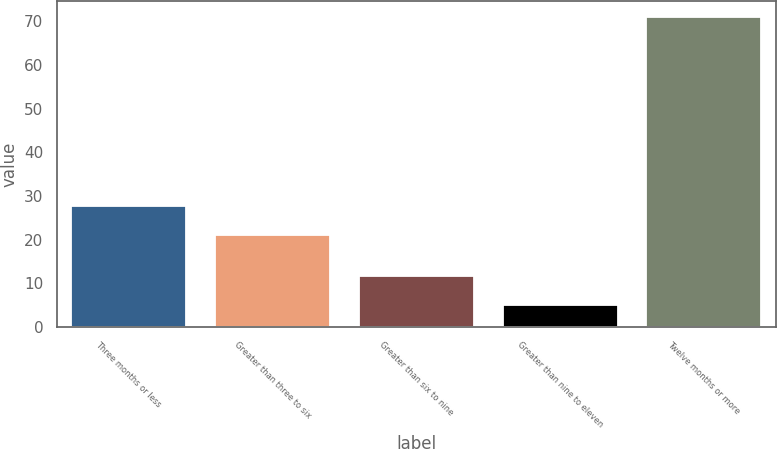<chart> <loc_0><loc_0><loc_500><loc_500><bar_chart><fcel>Three months or less<fcel>Greater than three to six<fcel>Greater than six to nine<fcel>Greater than nine to eleven<fcel>Twelve months or more<nl><fcel>27.6<fcel>21<fcel>11.6<fcel>5<fcel>71<nl></chart> 